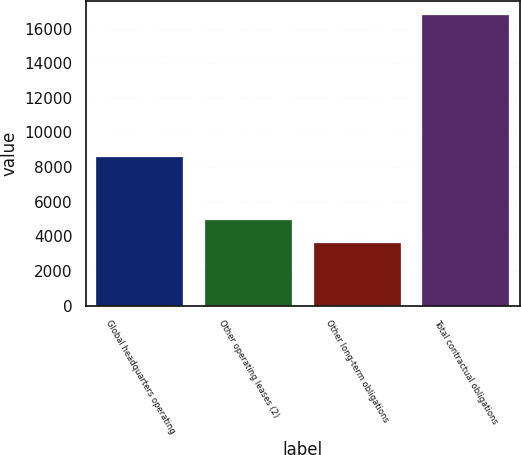Convert chart. <chart><loc_0><loc_0><loc_500><loc_500><bar_chart><fcel>Global headquarters operating<fcel>Other operating leases (2)<fcel>Other long-term obligations<fcel>Total contractual obligations<nl><fcel>8556<fcel>4926.9<fcel>3611<fcel>16770<nl></chart> 